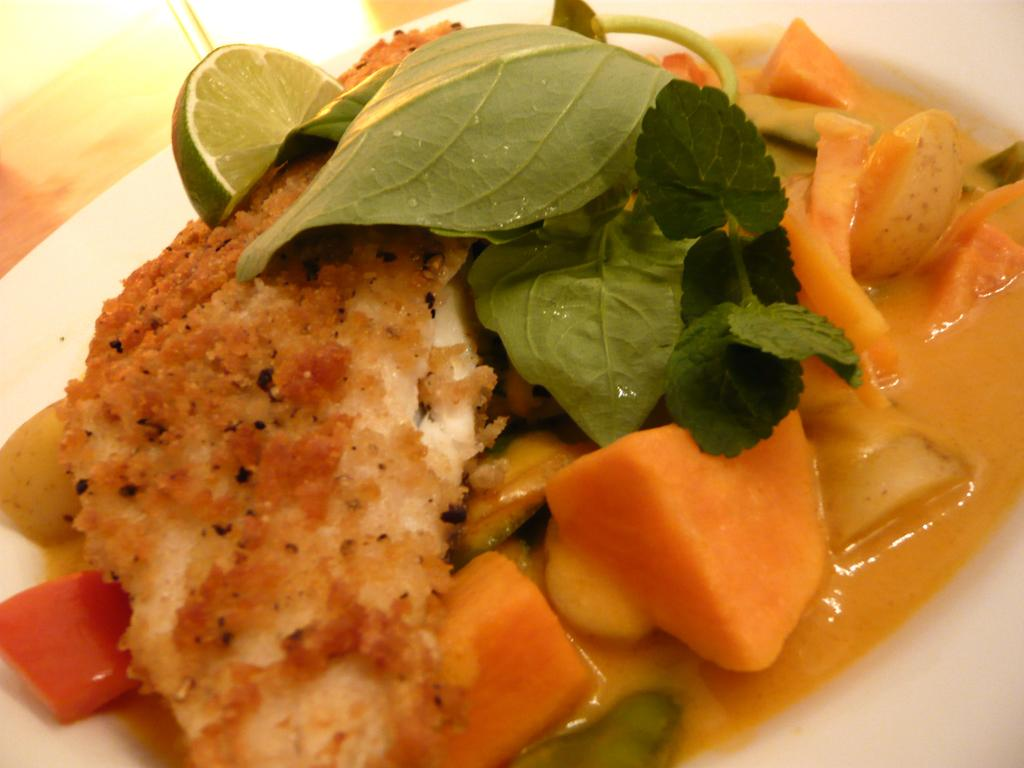What type of vegetable is present in the image? There is carrot in the image. What type of herb is present in the image? There are coriander leaves in the image. What type of fruit is present in the image? There is lemon in the image. What other items are present on a white color plate in the image? The provided facts do not specify what other items are on the white color plate. Can you tell me how many worms are crawling on the lemon in the image? There are no worms present in the image; it only features coriander leaves, carrot, and lemon. What type of pies are being served on the white color plate in the image? There is no mention of pies in the image; the provided facts only mention coriander leaves, carrot, and lemon. 